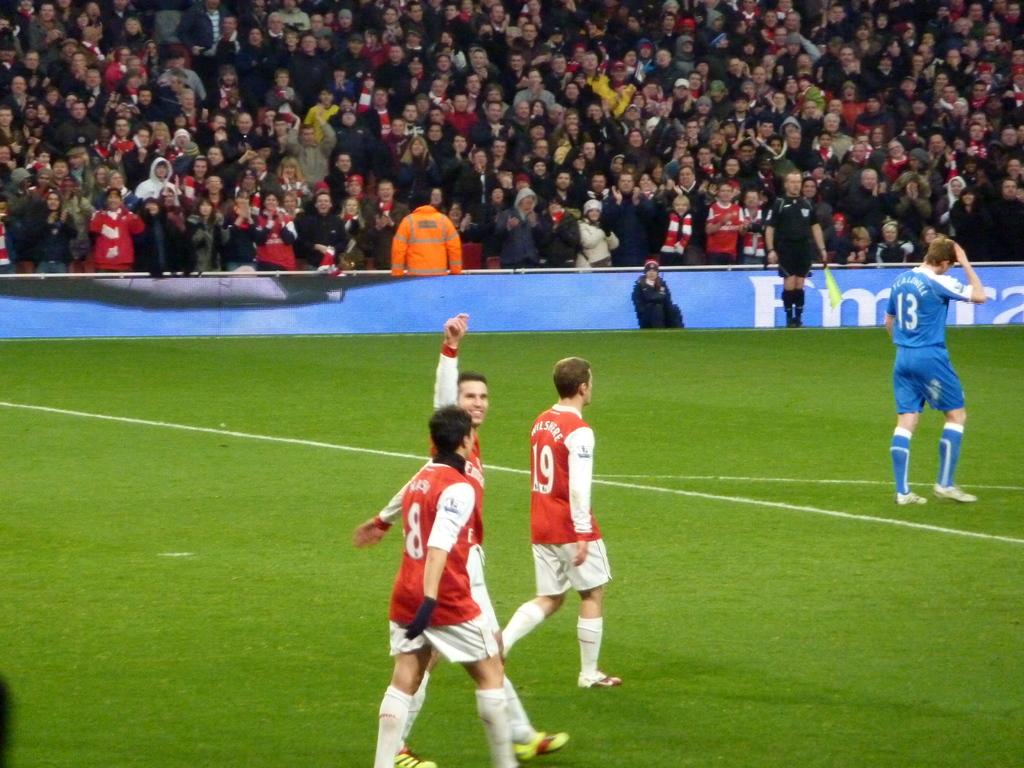<image>
Describe the image concisely. A player in a blue uniform with number 13 on the back has his hand on his head. 